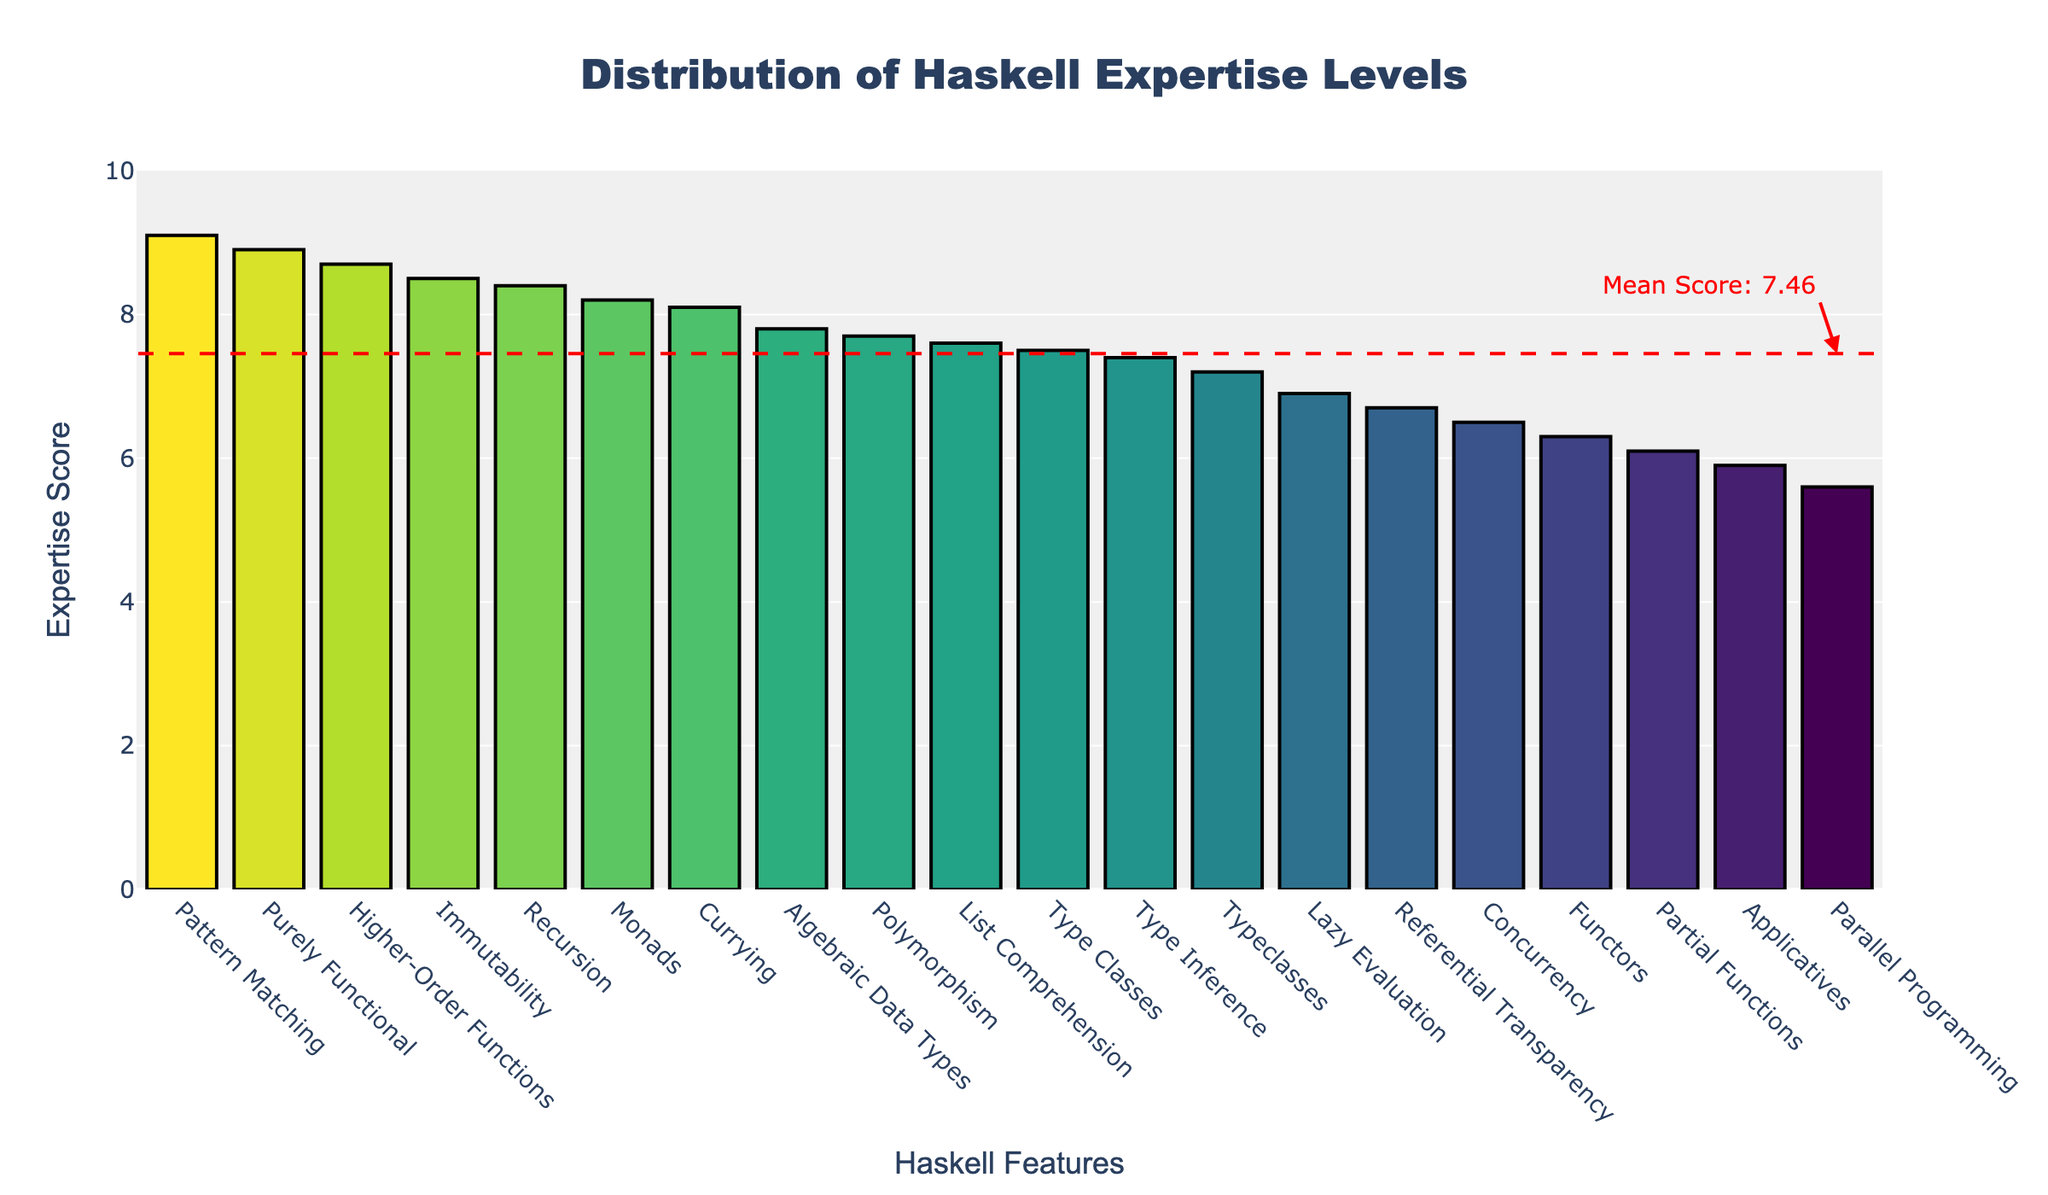what is the highest expertise score? The highest expertise score corresponds to the tallest bar in the plot, which is labeled "Pattern Matching." Its score is clearly marked at the top of the bar as 9.1.
Answer: 9.1 Which Haskell features have an expertise score above the mean score line? To answer this, identify the features with bars that reach above the red dashed mean score line. These features are: Pattern Matching, Purely Functional, Immutability, Higher-Order Functions, Monads, Currying, and Recursion.
Answer: 7 What is the expertise score for Lazy Evaluation and is it above or below the mean? Locate the "Lazy Evaluation" label on the x-axis and observe its bar height. Note the score (6.9) and compare it to the dashed mean score line. The mean score line is a bit above 7, so Lazy Evaluation is below it.
Answer: 6.9, below Which feature is the closest to the mean score? Compare each feature's bar height to the red dashed mean score line. "Typeclasses" has a score of 7.2, which appears closest to the mean score of around 7.3.
Answer: Typeclasses How many features have an expertise score below 6.0? Identify the bars extending below the 6.0 y-axis line. These features are: Applicatives (5.9) and Parallel Programming (5.6). There are 2 features in total.
Answer: 2 Rank the top three features in terms of expertise score. From tallest to shortest bars, the top three features are: Pattern Matching (9.1), Purely Functional (8.9), and Higher-Order Functions (8.7).
Answer: Pattern Matching, Purely Functional, Higher-Order Functions How does the expertise score for Concurrency compare to the scores for Monads, Recursion, and Immutability? The bar for "Concurrency" sits at 6.5. Comparing it to the bars for "Monads" (8.2), "Recursion" (8.4), and "Immutability" (8.5), it's clear that Concurrency has a lower score than all three.
Answer: Lower than all three What is the difference in expertise scores between the least and most experienced features? Identify the highest and lowest bars: Pattern Matching (9.1) and Parallel Programming (5.6). Calculate the difference as 9.1 - 5.6 = 3.5.
Answer: 3.5 Which feature has a score of exactly 8.5? Locate the bars and their labels along the x-axis, identifying the one that reaches the 8.5 y-axis line. The feature with the score of 8.5 is "Immutability."
Answer: Immutability What is the average score for features related to type system? Identify relevant bars: Type Classes (7.5), Typeclasses (7.2), Type Inference (7.4), Algebraic Data Types (7.8), Polymorphism (7.7). Calculate the average: (7.5 + 7.2 + 7.4 + 7.8 + 7.7) / 5 = 7.52.
Answer: 7.52 